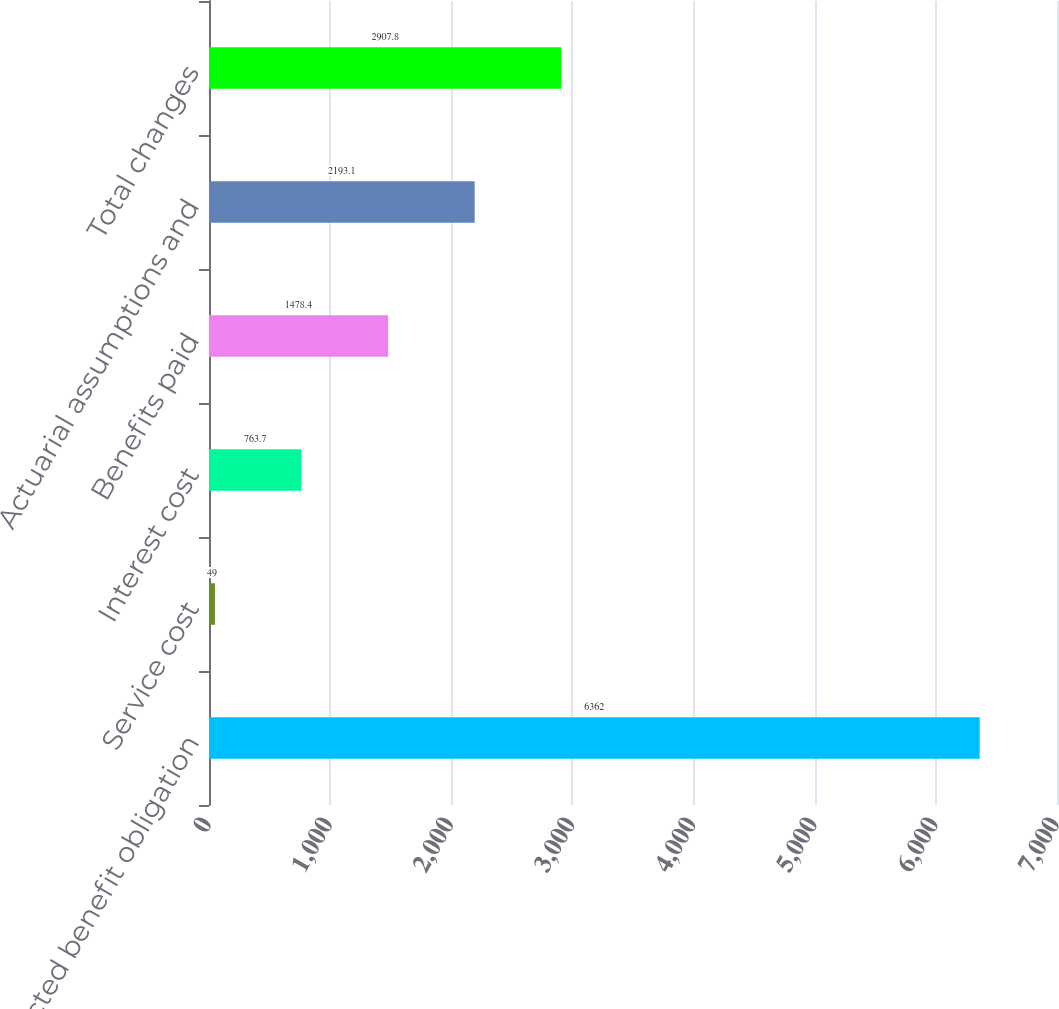Convert chart to OTSL. <chart><loc_0><loc_0><loc_500><loc_500><bar_chart><fcel>Projected benefit obligation<fcel>Service cost<fcel>Interest cost<fcel>Benefits paid<fcel>Actuarial assumptions and<fcel>Total changes<nl><fcel>6362<fcel>49<fcel>763.7<fcel>1478.4<fcel>2193.1<fcel>2907.8<nl></chart> 